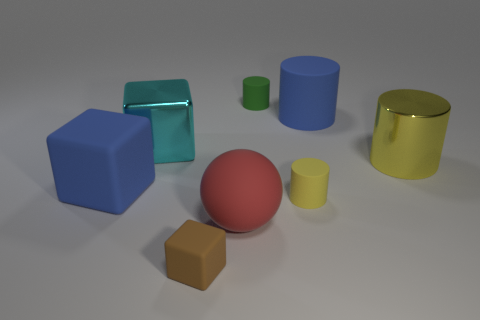If we were to group these objects based on their shapes, how many groups would there be and which objects belong to each group? Based on their shapes, we could group these objects into three categories. The first group would include the cylinders, which are the blue, green, and yellow objects. The second group contains the cubes, including the large blue block and the small brown block. Lastly, the red sphere stands alone in its own group as the only spherical object. 